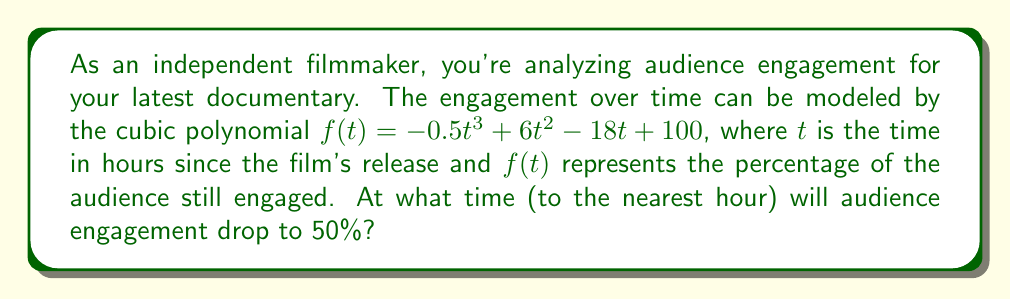What is the answer to this math problem? To solve this problem, we need to find the value of $t$ where $f(t) = 50$. This involves the following steps:

1) Set up the equation:
   $-0.5t^3 + 6t^2 - 18t + 100 = 50$

2) Rearrange to standard form:
   $-0.5t^3 + 6t^2 - 18t + 50 = 0$

3) This cubic equation doesn't have an easy factorization, so we'll use the method of successive approximation (also known as the bisection method).

4) Let's start by finding some boundary values:
   At $t = 0$: $f(0) = 100$
   At $t = 10$: $f(10) = -0.5(1000) + 6(100) - 18(10) + 100 = -500 + 600 - 180 + 100 = 20$

   So the solution lies between 0 and 10 hours.

5) Let's try $t = 5$:
   $f(5) = -0.5(125) + 6(25) - 18(5) + 100 = -62.5 + 150 - 90 + 100 = 97.5$

6) The solution is between 5 and 10. Let's try $t = 7$:
   $f(7) = -0.5(343) + 6(49) - 18(7) + 100 = -171.5 + 294 - 126 + 100 = 96.5$

7) Let's try $t = 9$:
   $f(9) = -0.5(729) + 6(81) - 18(9) + 100 = -364.5 + 486 - 162 + 100 = 59.5$

8) The solution is between 9 and 10. Let's try $t = 9.5$:
   $f(9.5) = -0.5(857.375) + 6(90.25) - 18(9.5) + 100 = -428.6875 + 541.5 - 171 + 100 = 41.8125$

Therefore, to the nearest hour, audience engagement will drop to 50% at 9 hours after the film's release.
Answer: 9 hours 